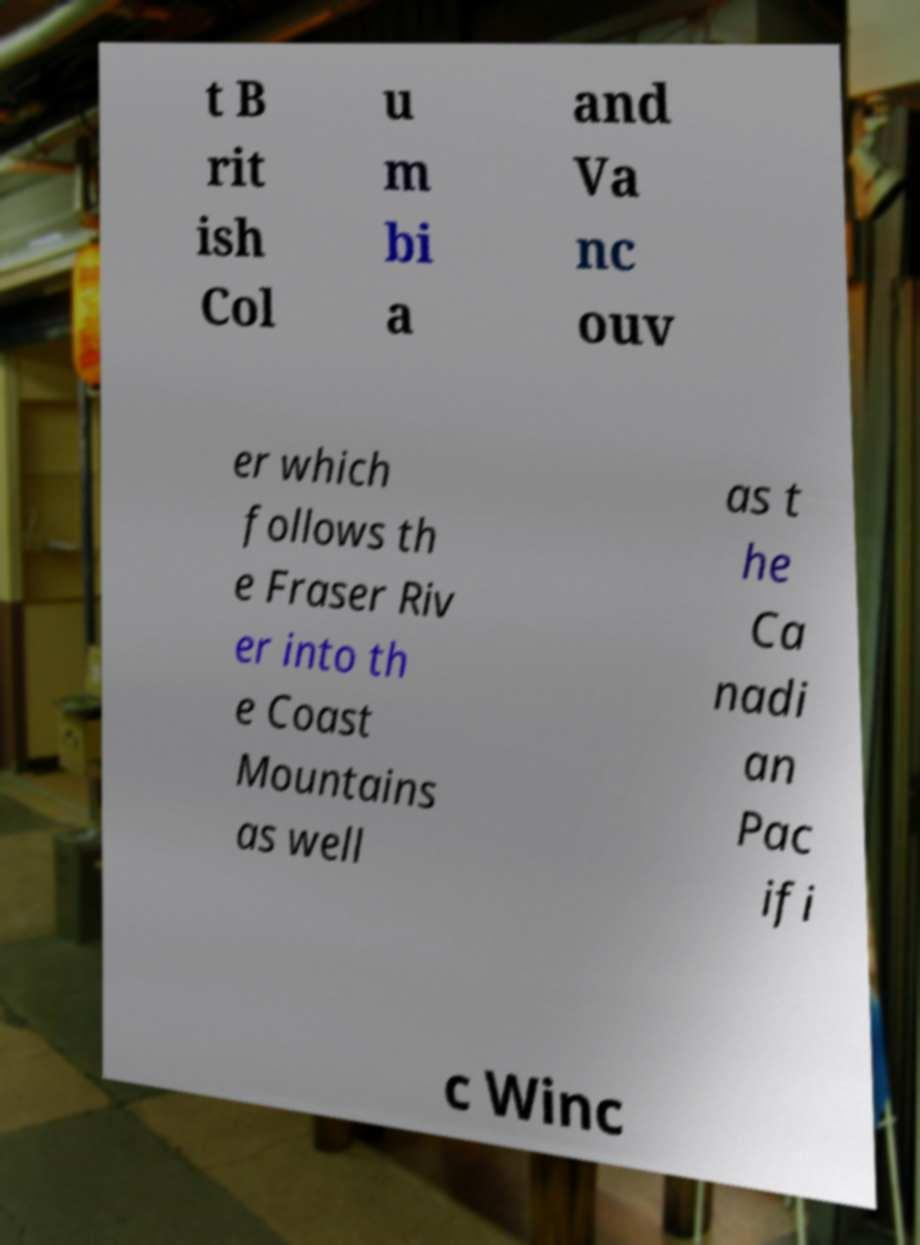Can you accurately transcribe the text from the provided image for me? t B rit ish Col u m bi a and Va nc ouv er which follows th e Fraser Riv er into th e Coast Mountains as well as t he Ca nadi an Pac ifi c Winc 